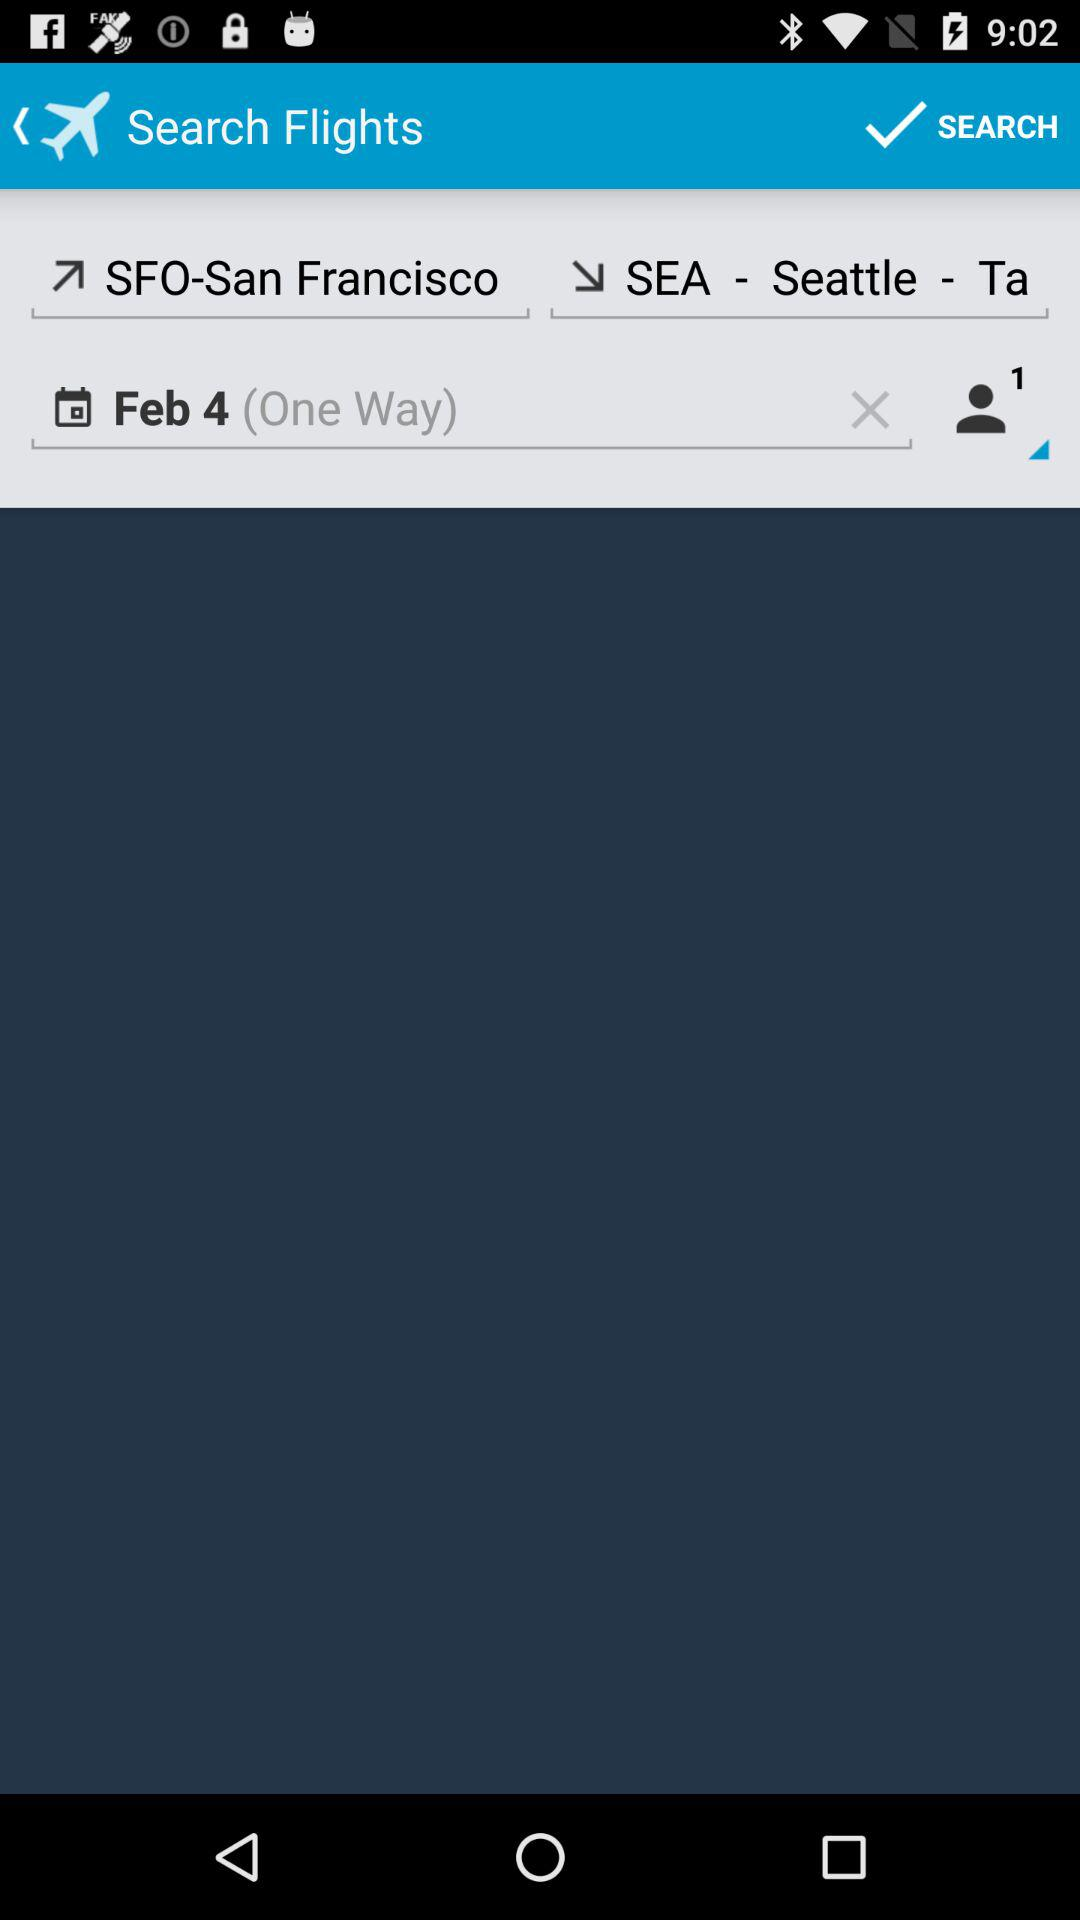How many people are traveling?
Answer the question using a single word or phrase. 1 